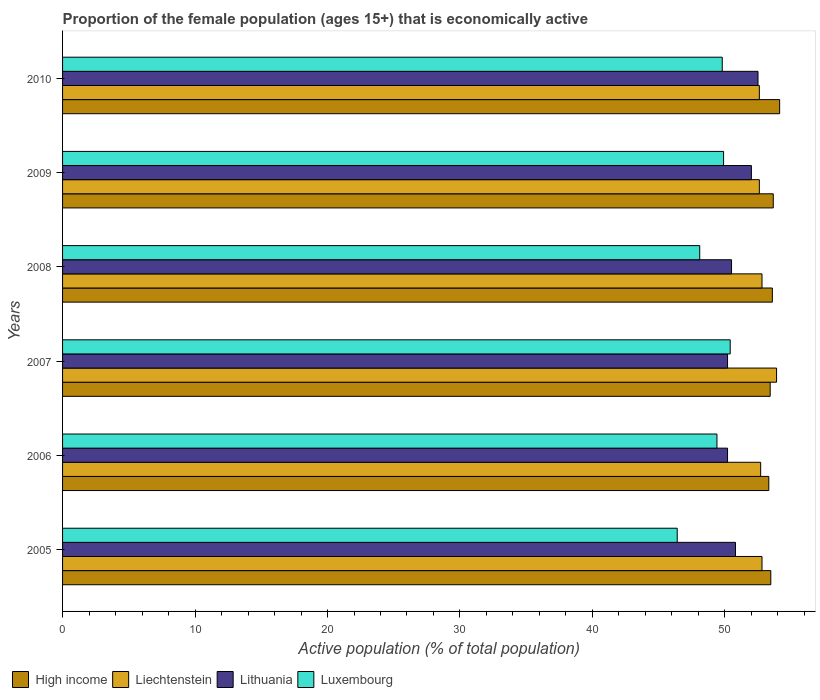Are the number of bars on each tick of the Y-axis equal?
Keep it short and to the point. Yes. How many bars are there on the 6th tick from the top?
Offer a terse response. 4. In how many cases, is the number of bars for a given year not equal to the number of legend labels?
Your response must be concise. 0. What is the proportion of the female population that is economically active in High income in 2008?
Your answer should be very brief. 53.58. Across all years, what is the maximum proportion of the female population that is economically active in Liechtenstein?
Make the answer very short. 53.9. Across all years, what is the minimum proportion of the female population that is economically active in Luxembourg?
Provide a succinct answer. 46.4. In which year was the proportion of the female population that is economically active in High income maximum?
Provide a succinct answer. 2010. In which year was the proportion of the female population that is economically active in Liechtenstein minimum?
Give a very brief answer. 2009. What is the total proportion of the female population that is economically active in High income in the graph?
Offer a very short reply. 321.56. What is the difference between the proportion of the female population that is economically active in High income in 2006 and that in 2010?
Your response must be concise. -0.82. What is the difference between the proportion of the female population that is economically active in Lithuania in 2006 and the proportion of the female population that is economically active in Liechtenstein in 2009?
Make the answer very short. -2.4. What is the average proportion of the female population that is economically active in Lithuania per year?
Make the answer very short. 51.03. In the year 2009, what is the difference between the proportion of the female population that is economically active in Luxembourg and proportion of the female population that is economically active in Lithuania?
Your answer should be compact. -2.1. In how many years, is the proportion of the female population that is economically active in High income greater than 6 %?
Provide a succinct answer. 6. What is the ratio of the proportion of the female population that is economically active in Luxembourg in 2005 to that in 2006?
Keep it short and to the point. 0.94. What is the difference between the highest and the second highest proportion of the female population that is economically active in High income?
Offer a terse response. 0.48. What is the difference between the highest and the lowest proportion of the female population that is economically active in Liechtenstein?
Your answer should be very brief. 1.3. Is the sum of the proportion of the female population that is economically active in Lithuania in 2007 and 2009 greater than the maximum proportion of the female population that is economically active in High income across all years?
Provide a succinct answer. Yes. Is it the case that in every year, the sum of the proportion of the female population that is economically active in Luxembourg and proportion of the female population that is economically active in Lithuania is greater than the sum of proportion of the female population that is economically active in Liechtenstein and proportion of the female population that is economically active in High income?
Offer a terse response. No. What does the 3rd bar from the top in 2005 represents?
Make the answer very short. Liechtenstein. What does the 4th bar from the bottom in 2006 represents?
Your answer should be compact. Luxembourg. Is it the case that in every year, the sum of the proportion of the female population that is economically active in Liechtenstein and proportion of the female population that is economically active in Luxembourg is greater than the proportion of the female population that is economically active in High income?
Offer a very short reply. Yes. How many bars are there?
Offer a very short reply. 24. Are all the bars in the graph horizontal?
Give a very brief answer. Yes. How many years are there in the graph?
Offer a terse response. 6. What is the difference between two consecutive major ticks on the X-axis?
Offer a terse response. 10. Are the values on the major ticks of X-axis written in scientific E-notation?
Offer a terse response. No. Does the graph contain grids?
Offer a very short reply. No. Where does the legend appear in the graph?
Your answer should be very brief. Bottom left. What is the title of the graph?
Make the answer very short. Proportion of the female population (ages 15+) that is economically active. Does "Greece" appear as one of the legend labels in the graph?
Keep it short and to the point. No. What is the label or title of the X-axis?
Provide a short and direct response. Active population (% of total population). What is the label or title of the Y-axis?
Provide a succinct answer. Years. What is the Active population (% of total population) of High income in 2005?
Ensure brevity in your answer.  53.46. What is the Active population (% of total population) of Liechtenstein in 2005?
Offer a very short reply. 52.8. What is the Active population (% of total population) of Lithuania in 2005?
Ensure brevity in your answer.  50.8. What is the Active population (% of total population) in Luxembourg in 2005?
Your answer should be compact. 46.4. What is the Active population (% of total population) of High income in 2006?
Your answer should be compact. 53.31. What is the Active population (% of total population) in Liechtenstein in 2006?
Provide a short and direct response. 52.7. What is the Active population (% of total population) of Lithuania in 2006?
Your response must be concise. 50.2. What is the Active population (% of total population) of Luxembourg in 2006?
Give a very brief answer. 49.4. What is the Active population (% of total population) in High income in 2007?
Your response must be concise. 53.42. What is the Active population (% of total population) of Liechtenstein in 2007?
Your response must be concise. 53.9. What is the Active population (% of total population) in Lithuania in 2007?
Your answer should be very brief. 50.2. What is the Active population (% of total population) of Luxembourg in 2007?
Ensure brevity in your answer.  50.4. What is the Active population (% of total population) of High income in 2008?
Provide a short and direct response. 53.58. What is the Active population (% of total population) of Liechtenstein in 2008?
Your answer should be compact. 52.8. What is the Active population (% of total population) in Lithuania in 2008?
Offer a terse response. 50.5. What is the Active population (% of total population) in Luxembourg in 2008?
Your answer should be compact. 48.1. What is the Active population (% of total population) in High income in 2009?
Offer a terse response. 53.65. What is the Active population (% of total population) in Liechtenstein in 2009?
Make the answer very short. 52.6. What is the Active population (% of total population) in Lithuania in 2009?
Ensure brevity in your answer.  52. What is the Active population (% of total population) in Luxembourg in 2009?
Make the answer very short. 49.9. What is the Active population (% of total population) of High income in 2010?
Provide a succinct answer. 54.13. What is the Active population (% of total population) of Liechtenstein in 2010?
Offer a terse response. 52.6. What is the Active population (% of total population) of Lithuania in 2010?
Offer a very short reply. 52.5. What is the Active population (% of total population) of Luxembourg in 2010?
Provide a succinct answer. 49.8. Across all years, what is the maximum Active population (% of total population) of High income?
Offer a very short reply. 54.13. Across all years, what is the maximum Active population (% of total population) of Liechtenstein?
Your answer should be compact. 53.9. Across all years, what is the maximum Active population (% of total population) in Lithuania?
Provide a succinct answer. 52.5. Across all years, what is the maximum Active population (% of total population) of Luxembourg?
Give a very brief answer. 50.4. Across all years, what is the minimum Active population (% of total population) of High income?
Offer a terse response. 53.31. Across all years, what is the minimum Active population (% of total population) of Liechtenstein?
Offer a terse response. 52.6. Across all years, what is the minimum Active population (% of total population) of Lithuania?
Your answer should be compact. 50.2. Across all years, what is the minimum Active population (% of total population) in Luxembourg?
Provide a short and direct response. 46.4. What is the total Active population (% of total population) of High income in the graph?
Ensure brevity in your answer.  321.56. What is the total Active population (% of total population) of Liechtenstein in the graph?
Give a very brief answer. 317.4. What is the total Active population (% of total population) of Lithuania in the graph?
Offer a very short reply. 306.2. What is the total Active population (% of total population) in Luxembourg in the graph?
Make the answer very short. 294. What is the difference between the Active population (% of total population) of High income in 2005 and that in 2006?
Offer a terse response. 0.15. What is the difference between the Active population (% of total population) of Liechtenstein in 2005 and that in 2006?
Your answer should be very brief. 0.1. What is the difference between the Active population (% of total population) of Luxembourg in 2005 and that in 2006?
Make the answer very short. -3. What is the difference between the Active population (% of total population) in High income in 2005 and that in 2007?
Offer a terse response. 0.05. What is the difference between the Active population (% of total population) in Liechtenstein in 2005 and that in 2007?
Give a very brief answer. -1.1. What is the difference between the Active population (% of total population) in Lithuania in 2005 and that in 2007?
Give a very brief answer. 0.6. What is the difference between the Active population (% of total population) of Luxembourg in 2005 and that in 2007?
Provide a succinct answer. -4. What is the difference between the Active population (% of total population) in High income in 2005 and that in 2008?
Your answer should be very brief. -0.12. What is the difference between the Active population (% of total population) of Liechtenstein in 2005 and that in 2008?
Ensure brevity in your answer.  0. What is the difference between the Active population (% of total population) in Lithuania in 2005 and that in 2008?
Keep it short and to the point. 0.3. What is the difference between the Active population (% of total population) of High income in 2005 and that in 2009?
Offer a very short reply. -0.19. What is the difference between the Active population (% of total population) of Liechtenstein in 2005 and that in 2009?
Provide a short and direct response. 0.2. What is the difference between the Active population (% of total population) in Lithuania in 2005 and that in 2009?
Offer a terse response. -1.2. What is the difference between the Active population (% of total population) of High income in 2005 and that in 2010?
Your response must be concise. -0.67. What is the difference between the Active population (% of total population) in Liechtenstein in 2005 and that in 2010?
Provide a succinct answer. 0.2. What is the difference between the Active population (% of total population) of Lithuania in 2005 and that in 2010?
Your answer should be compact. -1.7. What is the difference between the Active population (% of total population) in High income in 2006 and that in 2007?
Keep it short and to the point. -0.1. What is the difference between the Active population (% of total population) in Lithuania in 2006 and that in 2007?
Provide a short and direct response. 0. What is the difference between the Active population (% of total population) in Luxembourg in 2006 and that in 2007?
Your answer should be compact. -1. What is the difference between the Active population (% of total population) in High income in 2006 and that in 2008?
Provide a succinct answer. -0.27. What is the difference between the Active population (% of total population) in Luxembourg in 2006 and that in 2008?
Keep it short and to the point. 1.3. What is the difference between the Active population (% of total population) in High income in 2006 and that in 2009?
Your answer should be very brief. -0.34. What is the difference between the Active population (% of total population) of Liechtenstein in 2006 and that in 2009?
Provide a short and direct response. 0.1. What is the difference between the Active population (% of total population) in Lithuania in 2006 and that in 2009?
Offer a terse response. -1.8. What is the difference between the Active population (% of total population) of High income in 2006 and that in 2010?
Your response must be concise. -0.82. What is the difference between the Active population (% of total population) in Liechtenstein in 2006 and that in 2010?
Make the answer very short. 0.1. What is the difference between the Active population (% of total population) of High income in 2007 and that in 2008?
Your response must be concise. -0.16. What is the difference between the Active population (% of total population) in Lithuania in 2007 and that in 2008?
Provide a succinct answer. -0.3. What is the difference between the Active population (% of total population) in Luxembourg in 2007 and that in 2008?
Your answer should be compact. 2.3. What is the difference between the Active population (% of total population) of High income in 2007 and that in 2009?
Provide a short and direct response. -0.23. What is the difference between the Active population (% of total population) of Luxembourg in 2007 and that in 2009?
Your response must be concise. 0.5. What is the difference between the Active population (% of total population) of High income in 2007 and that in 2010?
Your answer should be very brief. -0.71. What is the difference between the Active population (% of total population) in Lithuania in 2007 and that in 2010?
Your response must be concise. -2.3. What is the difference between the Active population (% of total population) of Luxembourg in 2007 and that in 2010?
Ensure brevity in your answer.  0.6. What is the difference between the Active population (% of total population) in High income in 2008 and that in 2009?
Keep it short and to the point. -0.07. What is the difference between the Active population (% of total population) in Liechtenstein in 2008 and that in 2009?
Your answer should be very brief. 0.2. What is the difference between the Active population (% of total population) of Lithuania in 2008 and that in 2009?
Make the answer very short. -1.5. What is the difference between the Active population (% of total population) in High income in 2008 and that in 2010?
Offer a very short reply. -0.55. What is the difference between the Active population (% of total population) of Liechtenstein in 2008 and that in 2010?
Your answer should be compact. 0.2. What is the difference between the Active population (% of total population) of Luxembourg in 2008 and that in 2010?
Provide a short and direct response. -1.7. What is the difference between the Active population (% of total population) of High income in 2009 and that in 2010?
Ensure brevity in your answer.  -0.48. What is the difference between the Active population (% of total population) in Lithuania in 2009 and that in 2010?
Offer a very short reply. -0.5. What is the difference between the Active population (% of total population) in Luxembourg in 2009 and that in 2010?
Keep it short and to the point. 0.1. What is the difference between the Active population (% of total population) in High income in 2005 and the Active population (% of total population) in Liechtenstein in 2006?
Your response must be concise. 0.76. What is the difference between the Active population (% of total population) in High income in 2005 and the Active population (% of total population) in Lithuania in 2006?
Provide a succinct answer. 3.26. What is the difference between the Active population (% of total population) in High income in 2005 and the Active population (% of total population) in Luxembourg in 2006?
Your answer should be compact. 4.06. What is the difference between the Active population (% of total population) in Liechtenstein in 2005 and the Active population (% of total population) in Lithuania in 2006?
Your answer should be very brief. 2.6. What is the difference between the Active population (% of total population) in Liechtenstein in 2005 and the Active population (% of total population) in Luxembourg in 2006?
Provide a succinct answer. 3.4. What is the difference between the Active population (% of total population) in Lithuania in 2005 and the Active population (% of total population) in Luxembourg in 2006?
Ensure brevity in your answer.  1.4. What is the difference between the Active population (% of total population) of High income in 2005 and the Active population (% of total population) of Liechtenstein in 2007?
Provide a succinct answer. -0.44. What is the difference between the Active population (% of total population) in High income in 2005 and the Active population (% of total population) in Lithuania in 2007?
Ensure brevity in your answer.  3.26. What is the difference between the Active population (% of total population) in High income in 2005 and the Active population (% of total population) in Luxembourg in 2007?
Your answer should be compact. 3.06. What is the difference between the Active population (% of total population) of High income in 2005 and the Active population (% of total population) of Liechtenstein in 2008?
Offer a very short reply. 0.66. What is the difference between the Active population (% of total population) in High income in 2005 and the Active population (% of total population) in Lithuania in 2008?
Provide a succinct answer. 2.96. What is the difference between the Active population (% of total population) of High income in 2005 and the Active population (% of total population) of Luxembourg in 2008?
Your answer should be very brief. 5.36. What is the difference between the Active population (% of total population) in Liechtenstein in 2005 and the Active population (% of total population) in Lithuania in 2008?
Keep it short and to the point. 2.3. What is the difference between the Active population (% of total population) of High income in 2005 and the Active population (% of total population) of Liechtenstein in 2009?
Provide a short and direct response. 0.86. What is the difference between the Active population (% of total population) of High income in 2005 and the Active population (% of total population) of Lithuania in 2009?
Provide a succinct answer. 1.46. What is the difference between the Active population (% of total population) of High income in 2005 and the Active population (% of total population) of Luxembourg in 2009?
Ensure brevity in your answer.  3.56. What is the difference between the Active population (% of total population) of Liechtenstein in 2005 and the Active population (% of total population) of Lithuania in 2009?
Keep it short and to the point. 0.8. What is the difference between the Active population (% of total population) of Liechtenstein in 2005 and the Active population (% of total population) of Luxembourg in 2009?
Offer a very short reply. 2.9. What is the difference between the Active population (% of total population) in Lithuania in 2005 and the Active population (% of total population) in Luxembourg in 2009?
Make the answer very short. 0.9. What is the difference between the Active population (% of total population) of High income in 2005 and the Active population (% of total population) of Liechtenstein in 2010?
Make the answer very short. 0.86. What is the difference between the Active population (% of total population) of High income in 2005 and the Active population (% of total population) of Lithuania in 2010?
Your response must be concise. 0.96. What is the difference between the Active population (% of total population) in High income in 2005 and the Active population (% of total population) in Luxembourg in 2010?
Offer a very short reply. 3.66. What is the difference between the Active population (% of total population) in High income in 2006 and the Active population (% of total population) in Liechtenstein in 2007?
Offer a very short reply. -0.59. What is the difference between the Active population (% of total population) in High income in 2006 and the Active population (% of total population) in Lithuania in 2007?
Provide a succinct answer. 3.11. What is the difference between the Active population (% of total population) of High income in 2006 and the Active population (% of total population) of Luxembourg in 2007?
Your answer should be compact. 2.91. What is the difference between the Active population (% of total population) in Liechtenstein in 2006 and the Active population (% of total population) in Lithuania in 2007?
Offer a terse response. 2.5. What is the difference between the Active population (% of total population) of Liechtenstein in 2006 and the Active population (% of total population) of Luxembourg in 2007?
Your response must be concise. 2.3. What is the difference between the Active population (% of total population) of Lithuania in 2006 and the Active population (% of total population) of Luxembourg in 2007?
Your response must be concise. -0.2. What is the difference between the Active population (% of total population) in High income in 2006 and the Active population (% of total population) in Liechtenstein in 2008?
Provide a short and direct response. 0.51. What is the difference between the Active population (% of total population) of High income in 2006 and the Active population (% of total population) of Lithuania in 2008?
Make the answer very short. 2.81. What is the difference between the Active population (% of total population) of High income in 2006 and the Active population (% of total population) of Luxembourg in 2008?
Keep it short and to the point. 5.21. What is the difference between the Active population (% of total population) in Liechtenstein in 2006 and the Active population (% of total population) in Lithuania in 2008?
Make the answer very short. 2.2. What is the difference between the Active population (% of total population) in High income in 2006 and the Active population (% of total population) in Liechtenstein in 2009?
Provide a short and direct response. 0.71. What is the difference between the Active population (% of total population) in High income in 2006 and the Active population (% of total population) in Lithuania in 2009?
Your response must be concise. 1.31. What is the difference between the Active population (% of total population) of High income in 2006 and the Active population (% of total population) of Luxembourg in 2009?
Your answer should be compact. 3.41. What is the difference between the Active population (% of total population) in Liechtenstein in 2006 and the Active population (% of total population) in Lithuania in 2009?
Keep it short and to the point. 0.7. What is the difference between the Active population (% of total population) of Liechtenstein in 2006 and the Active population (% of total population) of Luxembourg in 2009?
Make the answer very short. 2.8. What is the difference between the Active population (% of total population) of Lithuania in 2006 and the Active population (% of total population) of Luxembourg in 2009?
Offer a terse response. 0.3. What is the difference between the Active population (% of total population) in High income in 2006 and the Active population (% of total population) in Liechtenstein in 2010?
Provide a short and direct response. 0.71. What is the difference between the Active population (% of total population) in High income in 2006 and the Active population (% of total population) in Lithuania in 2010?
Your answer should be very brief. 0.81. What is the difference between the Active population (% of total population) of High income in 2006 and the Active population (% of total population) of Luxembourg in 2010?
Your response must be concise. 3.51. What is the difference between the Active population (% of total population) of Liechtenstein in 2006 and the Active population (% of total population) of Luxembourg in 2010?
Your answer should be very brief. 2.9. What is the difference between the Active population (% of total population) of High income in 2007 and the Active population (% of total population) of Liechtenstein in 2008?
Your answer should be compact. 0.62. What is the difference between the Active population (% of total population) of High income in 2007 and the Active population (% of total population) of Lithuania in 2008?
Ensure brevity in your answer.  2.92. What is the difference between the Active population (% of total population) of High income in 2007 and the Active population (% of total population) of Luxembourg in 2008?
Provide a short and direct response. 5.32. What is the difference between the Active population (% of total population) in High income in 2007 and the Active population (% of total population) in Liechtenstein in 2009?
Ensure brevity in your answer.  0.82. What is the difference between the Active population (% of total population) of High income in 2007 and the Active population (% of total population) of Lithuania in 2009?
Your response must be concise. 1.42. What is the difference between the Active population (% of total population) in High income in 2007 and the Active population (% of total population) in Luxembourg in 2009?
Offer a very short reply. 3.52. What is the difference between the Active population (% of total population) in Liechtenstein in 2007 and the Active population (% of total population) in Lithuania in 2009?
Ensure brevity in your answer.  1.9. What is the difference between the Active population (% of total population) of Liechtenstein in 2007 and the Active population (% of total population) of Luxembourg in 2009?
Provide a succinct answer. 4. What is the difference between the Active population (% of total population) in High income in 2007 and the Active population (% of total population) in Liechtenstein in 2010?
Make the answer very short. 0.82. What is the difference between the Active population (% of total population) of High income in 2007 and the Active population (% of total population) of Lithuania in 2010?
Offer a very short reply. 0.92. What is the difference between the Active population (% of total population) of High income in 2007 and the Active population (% of total population) of Luxembourg in 2010?
Offer a terse response. 3.62. What is the difference between the Active population (% of total population) of Liechtenstein in 2007 and the Active population (% of total population) of Luxembourg in 2010?
Your answer should be very brief. 4.1. What is the difference between the Active population (% of total population) in High income in 2008 and the Active population (% of total population) in Liechtenstein in 2009?
Make the answer very short. 0.98. What is the difference between the Active population (% of total population) of High income in 2008 and the Active population (% of total population) of Lithuania in 2009?
Your answer should be very brief. 1.58. What is the difference between the Active population (% of total population) of High income in 2008 and the Active population (% of total population) of Luxembourg in 2009?
Keep it short and to the point. 3.68. What is the difference between the Active population (% of total population) of Liechtenstein in 2008 and the Active population (% of total population) of Lithuania in 2009?
Keep it short and to the point. 0.8. What is the difference between the Active population (% of total population) in High income in 2008 and the Active population (% of total population) in Liechtenstein in 2010?
Provide a succinct answer. 0.98. What is the difference between the Active population (% of total population) in High income in 2008 and the Active population (% of total population) in Lithuania in 2010?
Ensure brevity in your answer.  1.08. What is the difference between the Active population (% of total population) of High income in 2008 and the Active population (% of total population) of Luxembourg in 2010?
Provide a short and direct response. 3.78. What is the difference between the Active population (% of total population) of Liechtenstein in 2008 and the Active population (% of total population) of Lithuania in 2010?
Your response must be concise. 0.3. What is the difference between the Active population (% of total population) of Liechtenstein in 2008 and the Active population (% of total population) of Luxembourg in 2010?
Your answer should be compact. 3. What is the difference between the Active population (% of total population) in High income in 2009 and the Active population (% of total population) in Liechtenstein in 2010?
Your answer should be very brief. 1.05. What is the difference between the Active population (% of total population) in High income in 2009 and the Active population (% of total population) in Lithuania in 2010?
Your answer should be very brief. 1.15. What is the difference between the Active population (% of total population) of High income in 2009 and the Active population (% of total population) of Luxembourg in 2010?
Your response must be concise. 3.85. What is the difference between the Active population (% of total population) of Liechtenstein in 2009 and the Active population (% of total population) of Luxembourg in 2010?
Your answer should be very brief. 2.8. What is the difference between the Active population (% of total population) of Lithuania in 2009 and the Active population (% of total population) of Luxembourg in 2010?
Provide a succinct answer. 2.2. What is the average Active population (% of total population) in High income per year?
Provide a succinct answer. 53.59. What is the average Active population (% of total population) in Liechtenstein per year?
Your answer should be compact. 52.9. What is the average Active population (% of total population) in Lithuania per year?
Offer a terse response. 51.03. What is the average Active population (% of total population) in Luxembourg per year?
Offer a terse response. 49. In the year 2005, what is the difference between the Active population (% of total population) of High income and Active population (% of total population) of Liechtenstein?
Your response must be concise. 0.66. In the year 2005, what is the difference between the Active population (% of total population) in High income and Active population (% of total population) in Lithuania?
Provide a short and direct response. 2.66. In the year 2005, what is the difference between the Active population (% of total population) in High income and Active population (% of total population) in Luxembourg?
Make the answer very short. 7.06. In the year 2006, what is the difference between the Active population (% of total population) of High income and Active population (% of total population) of Liechtenstein?
Offer a terse response. 0.61. In the year 2006, what is the difference between the Active population (% of total population) of High income and Active population (% of total population) of Lithuania?
Your response must be concise. 3.11. In the year 2006, what is the difference between the Active population (% of total population) in High income and Active population (% of total population) in Luxembourg?
Offer a very short reply. 3.91. In the year 2006, what is the difference between the Active population (% of total population) of Lithuania and Active population (% of total population) of Luxembourg?
Your response must be concise. 0.8. In the year 2007, what is the difference between the Active population (% of total population) of High income and Active population (% of total population) of Liechtenstein?
Keep it short and to the point. -0.48. In the year 2007, what is the difference between the Active population (% of total population) in High income and Active population (% of total population) in Lithuania?
Your answer should be compact. 3.22. In the year 2007, what is the difference between the Active population (% of total population) of High income and Active population (% of total population) of Luxembourg?
Keep it short and to the point. 3.02. In the year 2007, what is the difference between the Active population (% of total population) in Liechtenstein and Active population (% of total population) in Lithuania?
Your answer should be compact. 3.7. In the year 2007, what is the difference between the Active population (% of total population) in Liechtenstein and Active population (% of total population) in Luxembourg?
Your answer should be very brief. 3.5. In the year 2007, what is the difference between the Active population (% of total population) in Lithuania and Active population (% of total population) in Luxembourg?
Your answer should be compact. -0.2. In the year 2008, what is the difference between the Active population (% of total population) of High income and Active population (% of total population) of Liechtenstein?
Ensure brevity in your answer.  0.78. In the year 2008, what is the difference between the Active population (% of total population) of High income and Active population (% of total population) of Lithuania?
Offer a terse response. 3.08. In the year 2008, what is the difference between the Active population (% of total population) of High income and Active population (% of total population) of Luxembourg?
Make the answer very short. 5.48. In the year 2008, what is the difference between the Active population (% of total population) in Lithuania and Active population (% of total population) in Luxembourg?
Your answer should be very brief. 2.4. In the year 2009, what is the difference between the Active population (% of total population) of High income and Active population (% of total population) of Liechtenstein?
Keep it short and to the point. 1.05. In the year 2009, what is the difference between the Active population (% of total population) of High income and Active population (% of total population) of Lithuania?
Your response must be concise. 1.65. In the year 2009, what is the difference between the Active population (% of total population) in High income and Active population (% of total population) in Luxembourg?
Offer a terse response. 3.75. In the year 2009, what is the difference between the Active population (% of total population) in Liechtenstein and Active population (% of total population) in Lithuania?
Your answer should be compact. 0.6. In the year 2009, what is the difference between the Active population (% of total population) in Liechtenstein and Active population (% of total population) in Luxembourg?
Make the answer very short. 2.7. In the year 2010, what is the difference between the Active population (% of total population) in High income and Active population (% of total population) in Liechtenstein?
Keep it short and to the point. 1.53. In the year 2010, what is the difference between the Active population (% of total population) in High income and Active population (% of total population) in Lithuania?
Offer a terse response. 1.63. In the year 2010, what is the difference between the Active population (% of total population) in High income and Active population (% of total population) in Luxembourg?
Ensure brevity in your answer.  4.33. In the year 2010, what is the difference between the Active population (% of total population) in Liechtenstein and Active population (% of total population) in Lithuania?
Your response must be concise. 0.1. What is the ratio of the Active population (% of total population) of Luxembourg in 2005 to that in 2006?
Offer a very short reply. 0.94. What is the ratio of the Active population (% of total population) of Liechtenstein in 2005 to that in 2007?
Give a very brief answer. 0.98. What is the ratio of the Active population (% of total population) of Luxembourg in 2005 to that in 2007?
Your answer should be compact. 0.92. What is the ratio of the Active population (% of total population) of High income in 2005 to that in 2008?
Provide a short and direct response. 1. What is the ratio of the Active population (% of total population) in Lithuania in 2005 to that in 2008?
Provide a succinct answer. 1.01. What is the ratio of the Active population (% of total population) of Luxembourg in 2005 to that in 2008?
Your response must be concise. 0.96. What is the ratio of the Active population (% of total population) in Liechtenstein in 2005 to that in 2009?
Your response must be concise. 1. What is the ratio of the Active population (% of total population) in Lithuania in 2005 to that in 2009?
Your response must be concise. 0.98. What is the ratio of the Active population (% of total population) of Luxembourg in 2005 to that in 2009?
Your answer should be compact. 0.93. What is the ratio of the Active population (% of total population) in Lithuania in 2005 to that in 2010?
Your response must be concise. 0.97. What is the ratio of the Active population (% of total population) of Luxembourg in 2005 to that in 2010?
Your response must be concise. 0.93. What is the ratio of the Active population (% of total population) in Liechtenstein in 2006 to that in 2007?
Keep it short and to the point. 0.98. What is the ratio of the Active population (% of total population) of Lithuania in 2006 to that in 2007?
Provide a succinct answer. 1. What is the ratio of the Active population (% of total population) in Luxembourg in 2006 to that in 2007?
Offer a terse response. 0.98. What is the ratio of the Active population (% of total population) of High income in 2006 to that in 2008?
Your answer should be compact. 0.99. What is the ratio of the Active population (% of total population) of Lithuania in 2006 to that in 2009?
Offer a very short reply. 0.97. What is the ratio of the Active population (% of total population) in Luxembourg in 2006 to that in 2009?
Offer a terse response. 0.99. What is the ratio of the Active population (% of total population) in High income in 2006 to that in 2010?
Your answer should be very brief. 0.98. What is the ratio of the Active population (% of total population) of Lithuania in 2006 to that in 2010?
Give a very brief answer. 0.96. What is the ratio of the Active population (% of total population) of Luxembourg in 2006 to that in 2010?
Provide a succinct answer. 0.99. What is the ratio of the Active population (% of total population) of Liechtenstein in 2007 to that in 2008?
Your answer should be very brief. 1.02. What is the ratio of the Active population (% of total population) in Lithuania in 2007 to that in 2008?
Give a very brief answer. 0.99. What is the ratio of the Active population (% of total population) in Luxembourg in 2007 to that in 2008?
Provide a succinct answer. 1.05. What is the ratio of the Active population (% of total population) of Liechtenstein in 2007 to that in 2009?
Your answer should be compact. 1.02. What is the ratio of the Active population (% of total population) of Lithuania in 2007 to that in 2009?
Your response must be concise. 0.97. What is the ratio of the Active population (% of total population) in Luxembourg in 2007 to that in 2009?
Make the answer very short. 1.01. What is the ratio of the Active population (% of total population) of High income in 2007 to that in 2010?
Keep it short and to the point. 0.99. What is the ratio of the Active population (% of total population) in Liechtenstein in 2007 to that in 2010?
Provide a succinct answer. 1.02. What is the ratio of the Active population (% of total population) of Lithuania in 2007 to that in 2010?
Ensure brevity in your answer.  0.96. What is the ratio of the Active population (% of total population) of Liechtenstein in 2008 to that in 2009?
Offer a very short reply. 1. What is the ratio of the Active population (% of total population) in Lithuania in 2008 to that in 2009?
Make the answer very short. 0.97. What is the ratio of the Active population (% of total population) in Luxembourg in 2008 to that in 2009?
Give a very brief answer. 0.96. What is the ratio of the Active population (% of total population) of Lithuania in 2008 to that in 2010?
Your answer should be very brief. 0.96. What is the ratio of the Active population (% of total population) in Luxembourg in 2008 to that in 2010?
Your response must be concise. 0.97. What is the ratio of the Active population (% of total population) in Luxembourg in 2009 to that in 2010?
Offer a terse response. 1. What is the difference between the highest and the second highest Active population (% of total population) of High income?
Keep it short and to the point. 0.48. What is the difference between the highest and the lowest Active population (% of total population) in High income?
Keep it short and to the point. 0.82. What is the difference between the highest and the lowest Active population (% of total population) of Liechtenstein?
Offer a terse response. 1.3. What is the difference between the highest and the lowest Active population (% of total population) of Lithuania?
Make the answer very short. 2.3. 